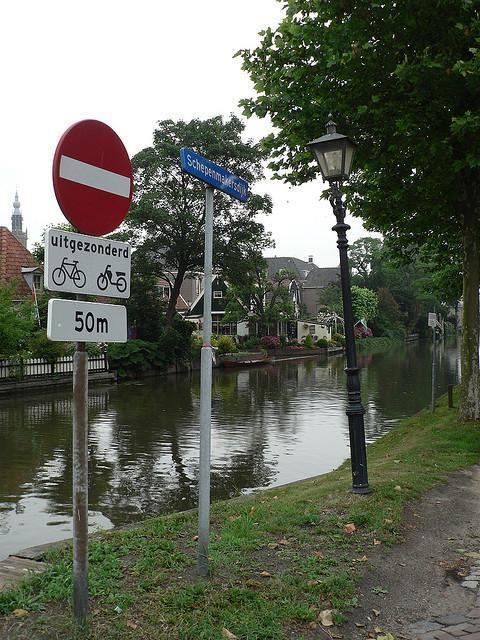How many people are carrying surfboards?
Give a very brief answer. 0. 